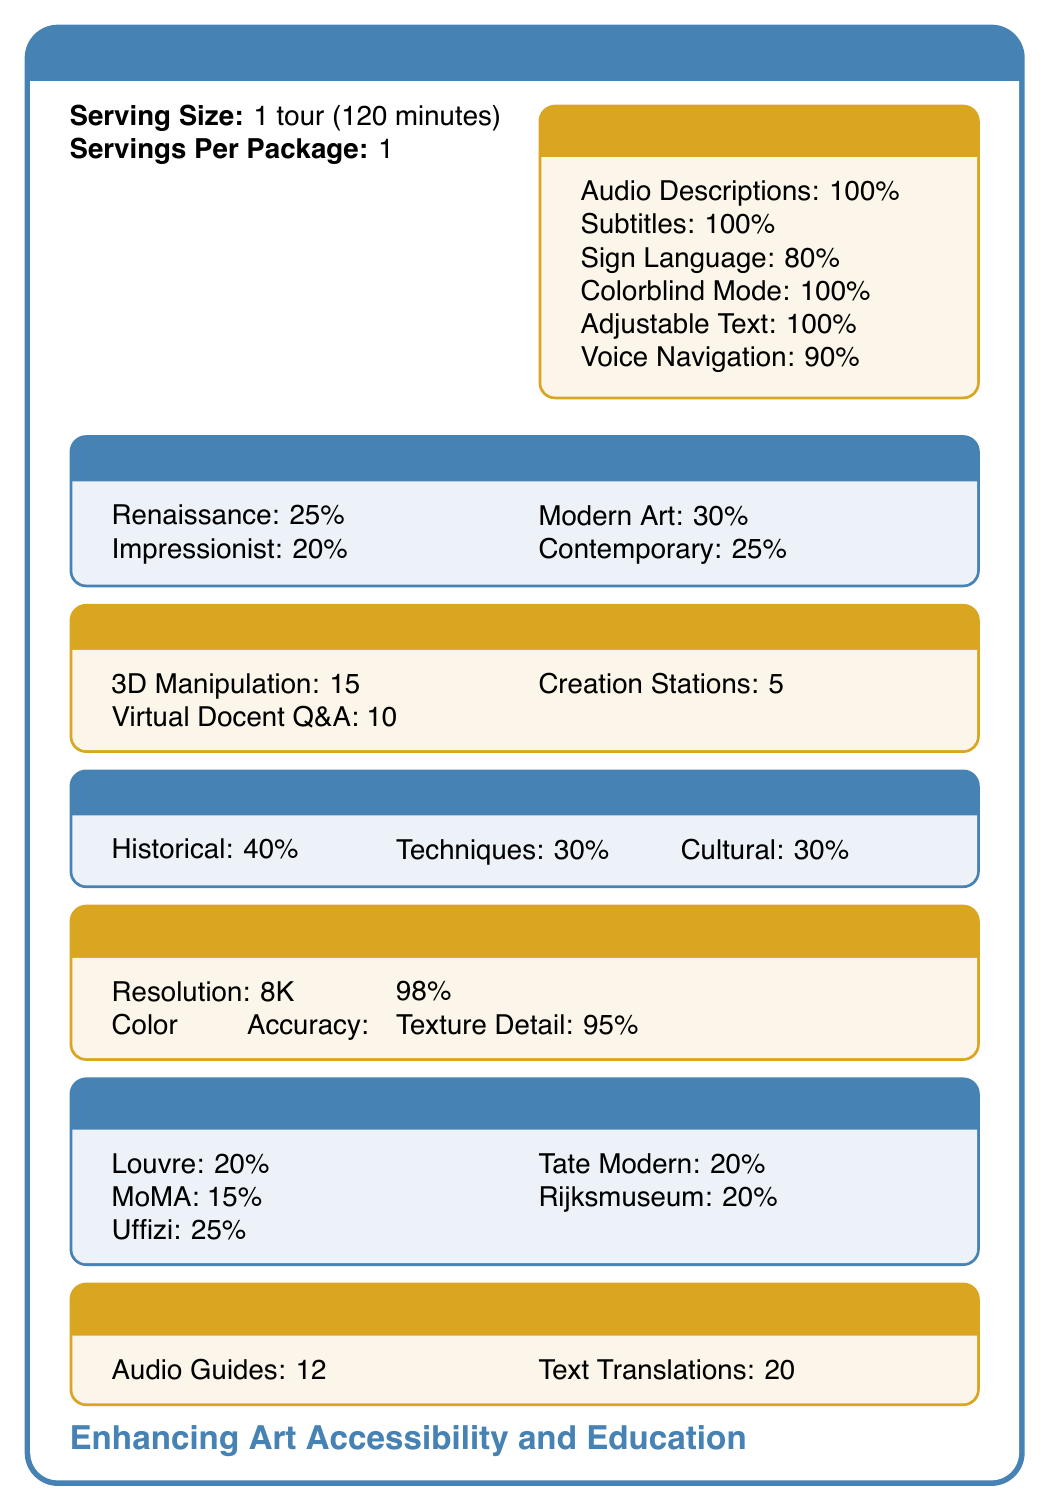which museum contributes the highest percentage of content? A. Louvre B. MoMA C. Uffizi Gallery D. Tate Modern E. Rijksmuseum The document states that the Uffizi Gallery provides 25% of the content, which is the highest among the listed museums.
Answer: C. Uffizi Gallery how long is each tour in the ArtVR Immersive Museum Tour? The serving size mentioned in the document is "1 tour (120 minutes)."
Answer: 120 minutes what percentage of the ArtVR tour is focused on Modern Art? Under "Art Historical Content," the document lists Modern Art as covering 30%.
Answer: 30% are there colorblind-friendly mode options available for the ArtVR tour? The Accessibility Features section lists Colorblind-friendly Mode as 100%.
Answer: Yes how many virtual docent Q&A opportunities are included in the ArtVR tour? The Interactive Elements section states that there are 10 Virtual Docent Q&A opportunities.
Answer: 10 opportunities what is the image resolution of the art reproductions in ArtVR? The Reproduction Quality section lists the image resolution as 8K (7680x4320).
Answer: 8K (7680x4320) what is the percentage of artworks from the Impressionist period in the ArtVR tour? The Art Historical Content section indicates that Impressionist Paintings make up 20% of the content.
Answer: 20% which museum partnership covers 20% of the content? A. Louvre B. MoMA C. Tate Modern D. Rijksmuseum Both Tate Modern and Rijksmuseum cover 20% of content, but only Tate Modern is an option in this question.
Answer: C. Tate Modern does the ArtVR tour offer voice control navigation? The document lists Voice Control Navigation as 90% under Accessibility Features.
Answer: Yes how many post-tour quizzes are available for the ArtVR tour? In the Supplementary Materials section, it is mentioned that there are 8 post-tour quizzes.
Answer: 8 summarize the main idea of the ArtVR Immersive Museum Tour document The document acts as a comprehensive guide to the ArtVR Immersive Museum Tour, detailing aspects like accessibility, types of art included, interactive features, educational benefits, and museum affiliations.
Answer: The document provides detailed information on the ArtVR Immersive Museum Tour, outlining accessibility features like audio descriptions and voice control, breakdowns of art historical content percentages, interactive elements, educational values, art reproduction quality, museum partnerships, language support, and supplementary materials. how advanced is the motion sickness reduction feature in the ArtVR tour? The Comfort Settings section states that Motion Sickness Reduction is "Advanced."
Answer: Advanced how adjustable is the walking speed in the ArtVR tour? The Comfort Settings section mentions that the walking speed is customizable from 0.5x to 2x.
Answer: 0.5x to 2x how many languages are available for audio guides in the ArtVR tour? The document states that Audio Guides are available in 12 languages.
Answer: 12 languages what fraction of the art periods covered does the Baroque period represent? The document lists Baroque as covering 15% under Art Periods Covered.
Answer: 15% which museum provides the least content contribution? The document indicates that the MoMA provides 15% of the content, which is the least among the listed museums.
Answer: MoMA how many downloadable e-books are available in the ArtVR tour? The Supplementary Materials section states that there are 5 downloadable e-books.
Answer: 5 does the document provide information about the pricing of the ArtVR tour? The document provides comprehensive details on features and content but does not provide any information on pricing.
Answer: Not enough information what is the primary focus of the ArtVR tour's educational value? A. Artistic Techniques B. Historical Context C. Cultural Impact The Educational Value section indicates that Historical Context accounts for 40%, which is the highest among the three options.
Answer: B. Historical Context 